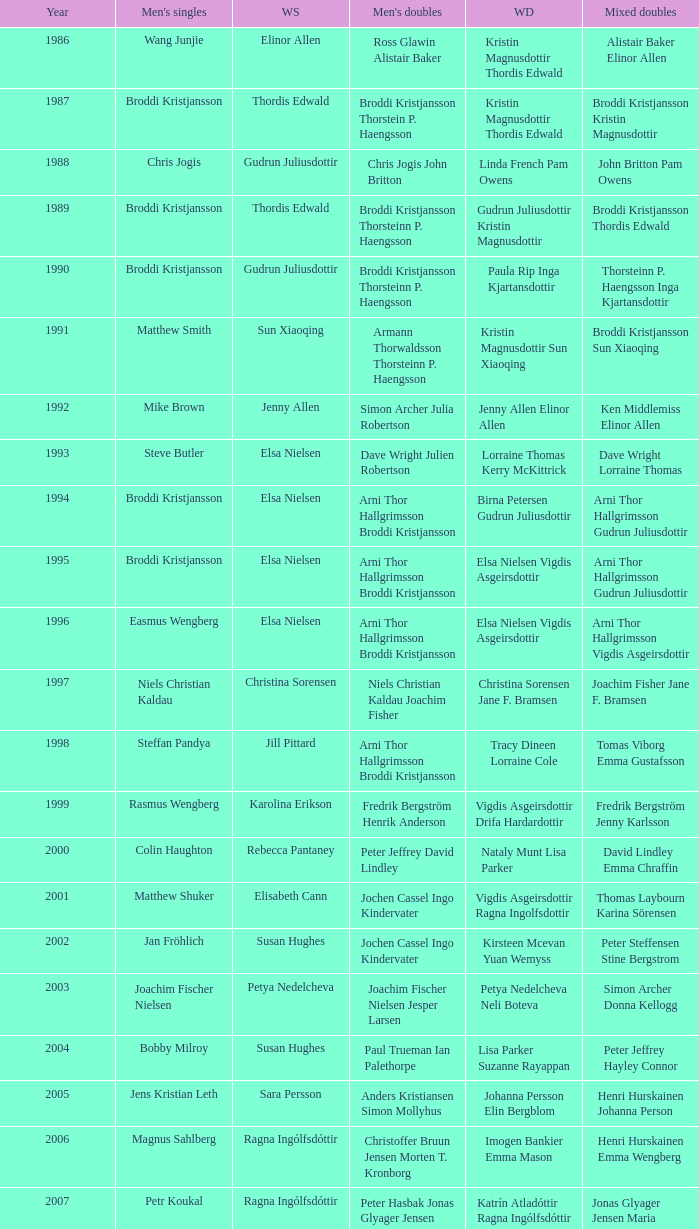Which mixed doubles happened later than 2011? Chou Tien-chen Chiang Mei-hui. 